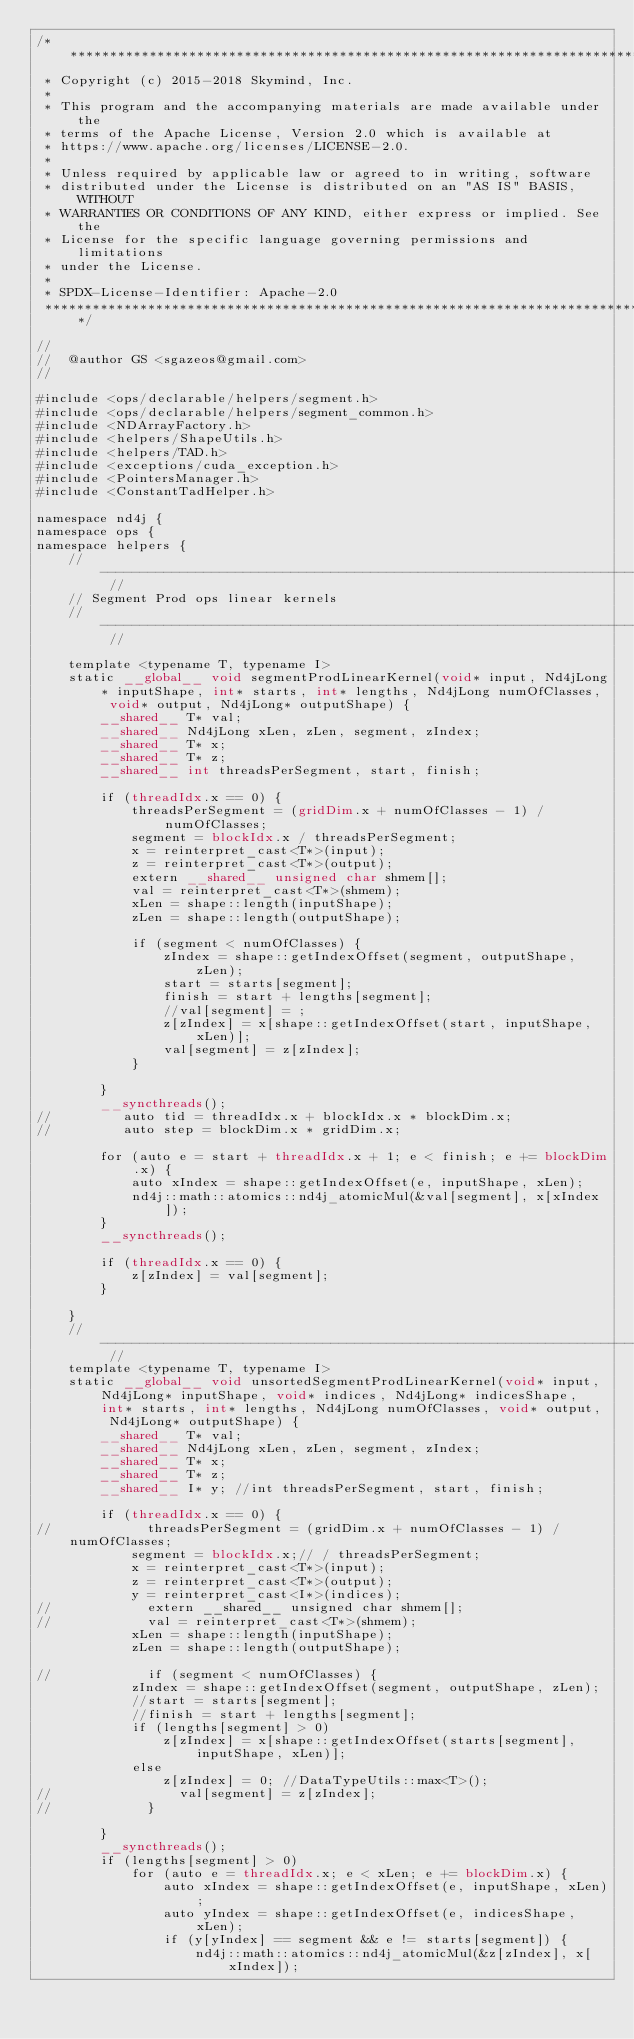<code> <loc_0><loc_0><loc_500><loc_500><_Cuda_>/*******************************************************************************
 * Copyright (c) 2015-2018 Skymind, Inc.
 *
 * This program and the accompanying materials are made available under the
 * terms of the Apache License, Version 2.0 which is available at
 * https://www.apache.org/licenses/LICENSE-2.0.
 *
 * Unless required by applicable law or agreed to in writing, software
 * distributed under the License is distributed on an "AS IS" BASIS, WITHOUT
 * WARRANTIES OR CONDITIONS OF ANY KIND, either express or implied. See the
 * License for the specific language governing permissions and limitations
 * under the License.
 *
 * SPDX-License-Identifier: Apache-2.0
 ******************************************************************************/

//
//  @author GS <sgazeos@gmail.com>
//

#include <ops/declarable/helpers/segment.h>
#include <ops/declarable/helpers/segment_common.h>
#include <NDArrayFactory.h>
#include <helpers/ShapeUtils.h>
#include <helpers/TAD.h>
#include <exceptions/cuda_exception.h>
#include <PointersManager.h>
#include <ConstantTadHelper.h>

namespace nd4j {
namespace ops {
namespace helpers {
    // -------------------------------------------------------------------------------------------------------------- //
    // Segment Prod ops linear kernels
    // -------------------------------------------------------------------------------------------------------------- //

    template <typename T, typename I>
    static __global__ void segmentProdLinearKernel(void* input, Nd4jLong* inputShape, int* starts, int* lengths, Nd4jLong numOfClasses, void* output, Nd4jLong* outputShape) {
        __shared__ T* val;
        __shared__ Nd4jLong xLen, zLen, segment, zIndex;
        __shared__ T* x;
        __shared__ T* z;
        __shared__ int threadsPerSegment, start, finish;

        if (threadIdx.x == 0) {
            threadsPerSegment = (gridDim.x + numOfClasses - 1) / numOfClasses;
            segment = blockIdx.x / threadsPerSegment;
            x = reinterpret_cast<T*>(input);
            z = reinterpret_cast<T*>(output);
            extern __shared__ unsigned char shmem[];
            val = reinterpret_cast<T*>(shmem);
            xLen = shape::length(inputShape);
            zLen = shape::length(outputShape);

            if (segment < numOfClasses) {
                zIndex = shape::getIndexOffset(segment, outputShape, zLen);
                start = starts[segment];
                finish = start + lengths[segment];
                //val[segment] = ;
                z[zIndex] = x[shape::getIndexOffset(start, inputShape, xLen)];
                val[segment] = z[zIndex];
            }

        }
        __syncthreads();
//         auto tid = threadIdx.x + blockIdx.x * blockDim.x;
//         auto step = blockDim.x * gridDim.x;

        for (auto e = start + threadIdx.x + 1; e < finish; e += blockDim.x) {
            auto xIndex = shape::getIndexOffset(e, inputShape, xLen);
            nd4j::math::atomics::nd4j_atomicMul(&val[segment], x[xIndex]);
        }
        __syncthreads();

        if (threadIdx.x == 0) {
            z[zIndex] = val[segment];
        }

    }
    // -------------------------------------------------------------------------------------------------------------- //
    template <typename T, typename I>
    static __global__ void unsortedSegmentProdLinearKernel(void* input, Nd4jLong* inputShape, void* indices, Nd4jLong* indicesShape, int* starts, int* lengths, Nd4jLong numOfClasses, void* output, Nd4jLong* outputShape) {
        __shared__ T* val;
        __shared__ Nd4jLong xLen, zLen, segment, zIndex;
        __shared__ T* x;
        __shared__ T* z;
        __shared__ I* y; //int threadsPerSegment, start, finish;

        if (threadIdx.x == 0) {
//            threadsPerSegment = (gridDim.x + numOfClasses - 1) / numOfClasses;
            segment = blockIdx.x;// / threadsPerSegment;
            x = reinterpret_cast<T*>(input);
            z = reinterpret_cast<T*>(output);
            y = reinterpret_cast<I*>(indices);
//            extern __shared__ unsigned char shmem[];
//            val = reinterpret_cast<T*>(shmem);
            xLen = shape::length(inputShape);
            zLen = shape::length(outputShape);

//            if (segment < numOfClasses) {
            zIndex = shape::getIndexOffset(segment, outputShape, zLen);
            //start = starts[segment];
            //finish = start + lengths[segment];
            if (lengths[segment] > 0)
                z[zIndex] = x[shape::getIndexOffset(starts[segment], inputShape, xLen)];
            else
                z[zIndex] = 0; //DataTypeUtils::max<T>();
//                val[segment] = z[zIndex];
//            }

        }
        __syncthreads();
        if (lengths[segment] > 0)
            for (auto e = threadIdx.x; e < xLen; e += blockDim.x) {
                auto xIndex = shape::getIndexOffset(e, inputShape, xLen);
                auto yIndex = shape::getIndexOffset(e, indicesShape, xLen);
                if (y[yIndex] == segment && e != starts[segment]) {
                    nd4j::math::atomics::nd4j_atomicMul(&z[zIndex], x[xIndex]);</code> 